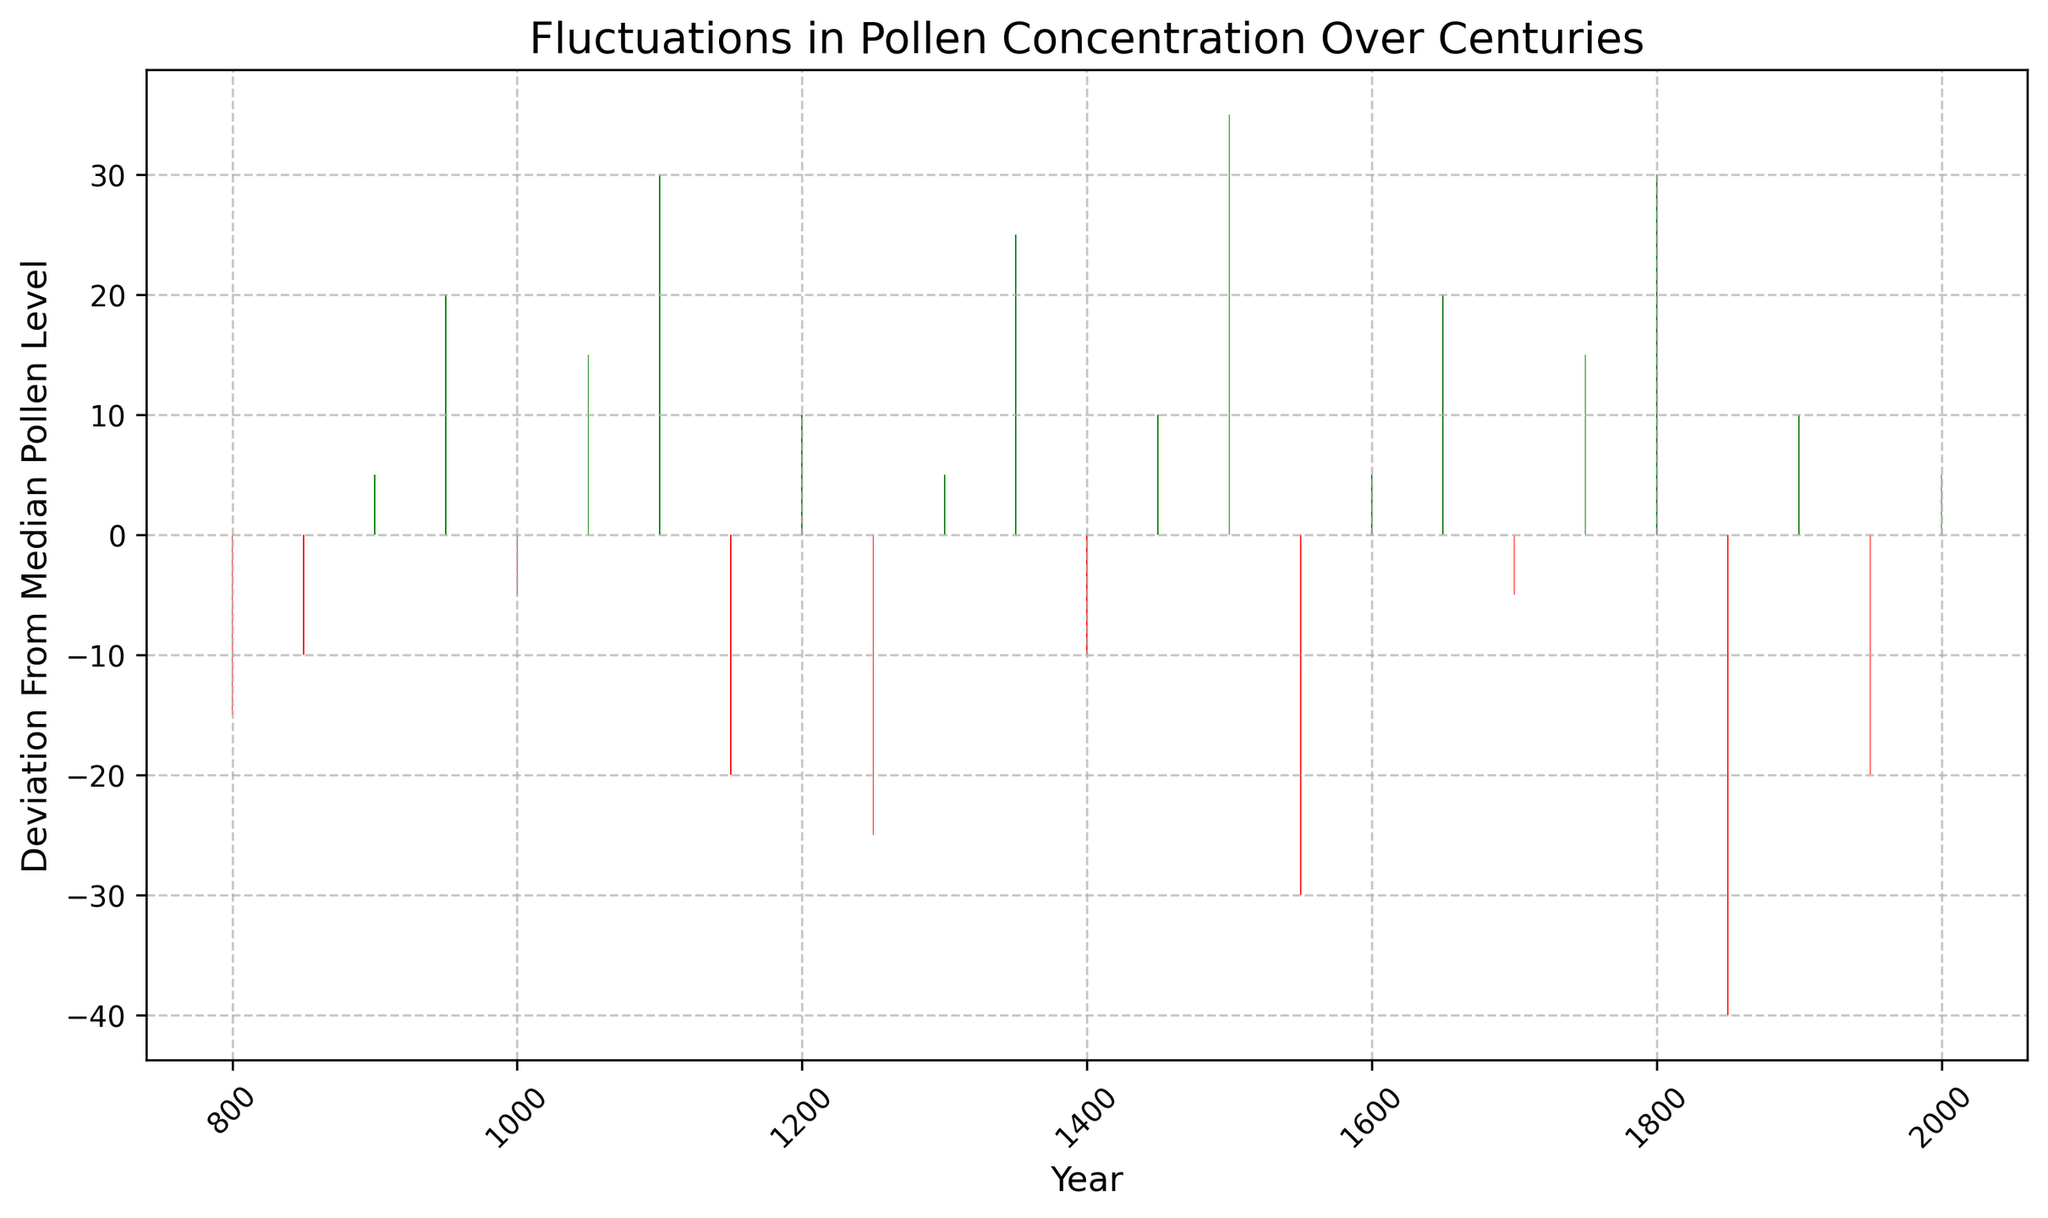Which year has the highest positive deviation from the median pollen level? The tallest green bar represents the highest positive deviation. Observing the green bars, the tallest one corresponds to the year 1500, so the highest positive deviation from the median pollen level is in the year 1500.
Answer: 1500 What is the overall trend in pollen deviations from the year 1150 to 1250? To understand the trend, observe the height and color of the bars from 1150 to 1250. The deviation starts at -20 in 1150 (red) and decreases further to -25 in 1250 (red), showing a negative trend in pollen deviation during this period.
Answer: Negative trend Between which centuries is the largest fluctuation in pollen levels observed? Review the fluctuations by inspecting the tallest bars. The largest fluctuation is the difference between the highest positive bar (1500, +35) and the lowest negative bar (1850, -40). The centuries are 16th (1500s) and 19th (1800s).
Answer: 16th and 19th centuries How many centuries show a negative deviation in pollen levels? Count the number of red bars, which represent negative deviations, and identify the corresponding century ranges. There are notable red bars in the years 800, 850, 1000, 1150, 1250, 1400, 1550, 1700, 1850, and 1950, spanning the corresponding centuries.
Answer: 10 centuries Are there more years with positive deviations or negative deviations? Compare the number of green (positive) bars to red (negative) bars. Green bars are for 900, 950, 1050, 1100, 1200, 1300, 1350, 1450, 1500, 1600, 1650, 1800, and 2000, totaling 13. Red bars are for 800, 850, 1000, 1150, 1250, 1400, 1550, 1700, 1850, and 1950, totaling 10.
Answer: Positive deviations What is the sum of the deviations from the median pollen level in the 12th century (1100-1199)? Identify and sum the deviations within the 12th century, specifically for the years 1100 and 1150. The deviations are 30 and -20. The sum is 30 + (-20), which equals 10.
Answer: 10 In which year did the deviation from the median pollen level fall below -20? Look for the red bars with a height less than -20. The only year with such deviation is 1850, with a deviation of -40.
Answer: 1850 Which decade had the second highest positive deviation? Identify the second tallest green bar. The tallest is in 1500 (+35), and the second tallest is in 1800 (+30). So, the year 1800 shows the second highest positive deviation.
Answer: 1800 When did the pollen deviation last enter the positive range before 2000? Identify the last green bar before the year 2000. The green bar prior to 2000 is in 1950, indicating the decade before the last positive deviation.
Answer: 1950 What was the deviation from the median pollen level in the year 1600? Locate the bar for the year 1600 and observe its height. The deviation for 1600 is +5 as represented by the green bar.
Answer: +5 